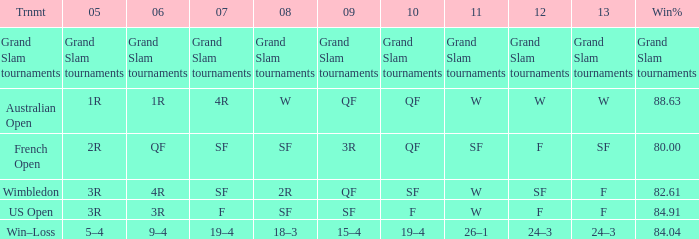Could you parse the entire table as a dict? {'header': ['Trnmt', '05', '06', '07', '08', '09', '10', '11', '12', '13', 'Win%'], 'rows': [['Grand Slam tournaments', 'Grand Slam tournaments', 'Grand Slam tournaments', 'Grand Slam tournaments', 'Grand Slam tournaments', 'Grand Slam tournaments', 'Grand Slam tournaments', 'Grand Slam tournaments', 'Grand Slam tournaments', 'Grand Slam tournaments', 'Grand Slam tournaments'], ['Australian Open', '1R', '1R', '4R', 'W', 'QF', 'QF', 'W', 'W', 'W', '88.63'], ['French Open', '2R', 'QF', 'SF', 'SF', '3R', 'QF', 'SF', 'F', 'SF', '80.00'], ['Wimbledon', '3R', '4R', 'SF', '2R', 'QF', 'SF', 'W', 'SF', 'F', '82.61'], ['US Open', '3R', '3R', 'F', 'SF', 'SF', 'F', 'W', 'F', 'F', '84.91'], ['Win–Loss', '5–4', '9–4', '19–4', '18–3', '15–4', '19–4', '26–1', '24–3', '24–3', '84.04']]} What in 2013 has a 2009 of 3r? SF. 